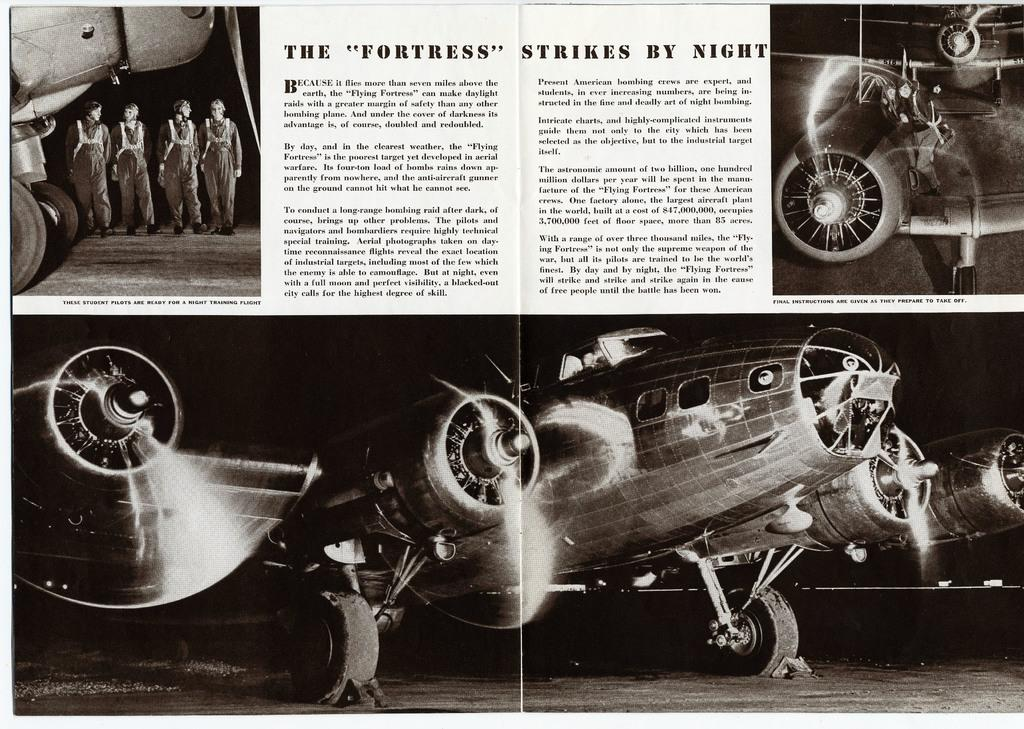What is featured on the poster in the image? The poster has pictures of a helicopter. Are there any people in the image? Yes, there are people beside the poster. What else can be seen on the poster besides the helicopter pictures? There is text written on the poster. How many cacti are visible in the image? There are no cacti present in the image. Are there any rabbits visible in the image? There are no rabbits present in the image. 